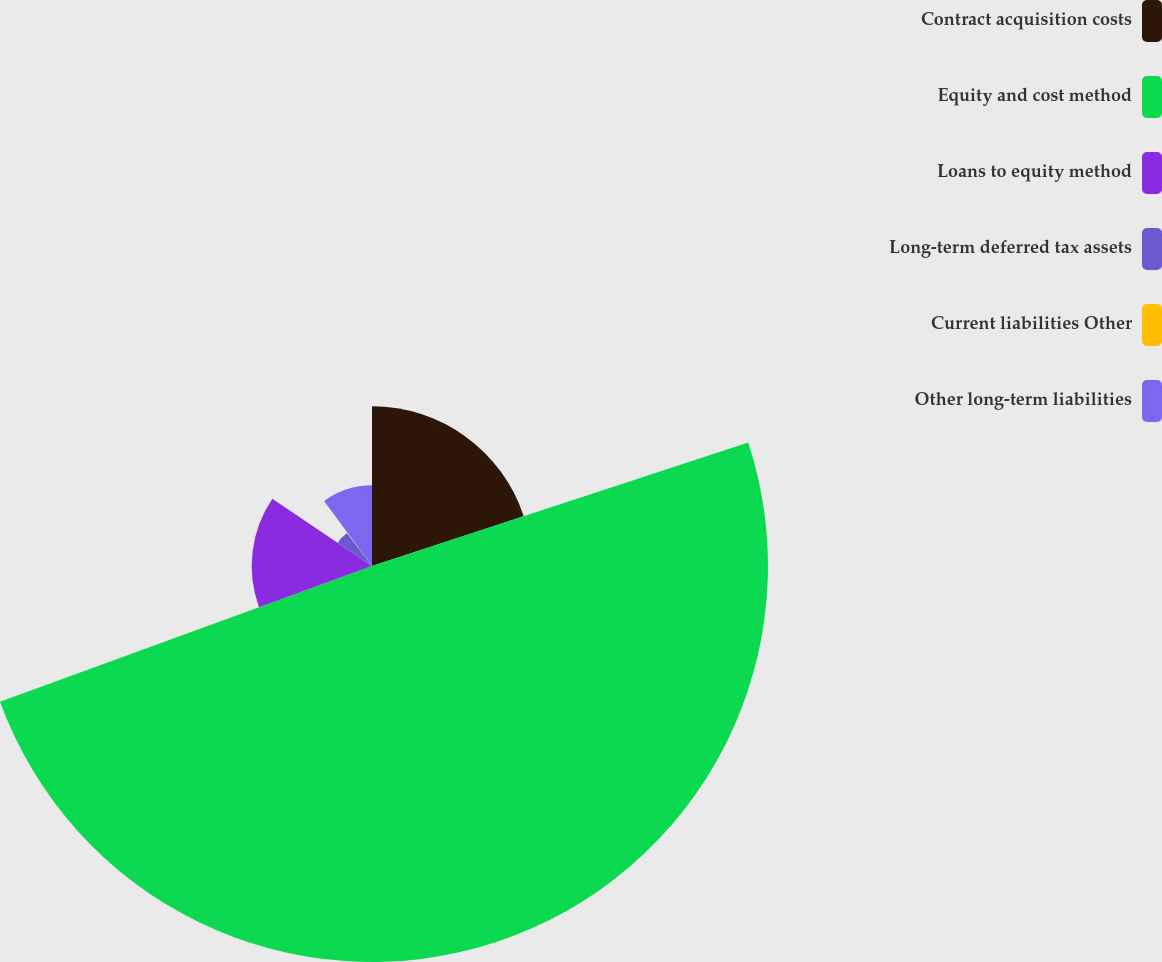<chart> <loc_0><loc_0><loc_500><loc_500><pie_chart><fcel>Contract acquisition costs<fcel>Equity and cost method<fcel>Loans to equity method<fcel>Long-term deferred tax assets<fcel>Current liabilities Other<fcel>Other long-term liabilities<nl><fcel>19.95%<fcel>49.48%<fcel>15.03%<fcel>5.18%<fcel>0.26%<fcel>10.1%<nl></chart> 